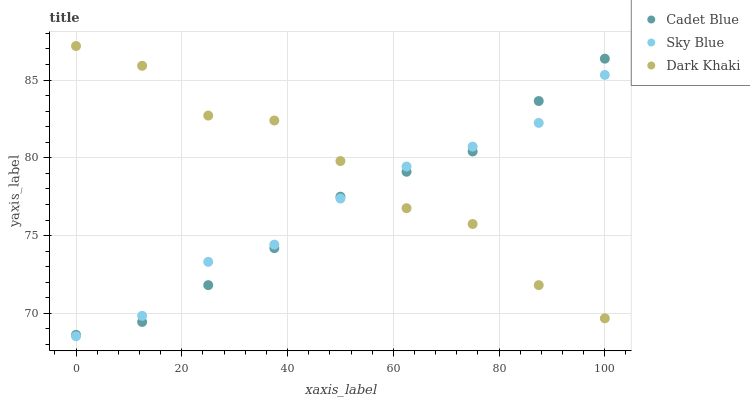Does Cadet Blue have the minimum area under the curve?
Answer yes or no. Yes. Does Dark Khaki have the maximum area under the curve?
Answer yes or no. Yes. Does Sky Blue have the minimum area under the curve?
Answer yes or no. No. Does Sky Blue have the maximum area under the curve?
Answer yes or no. No. Is Cadet Blue the smoothest?
Answer yes or no. Yes. Is Dark Khaki the roughest?
Answer yes or no. Yes. Is Sky Blue the smoothest?
Answer yes or no. No. Is Sky Blue the roughest?
Answer yes or no. No. Does Sky Blue have the lowest value?
Answer yes or no. Yes. Does Cadet Blue have the lowest value?
Answer yes or no. No. Does Dark Khaki have the highest value?
Answer yes or no. Yes. Does Cadet Blue have the highest value?
Answer yes or no. No. Does Sky Blue intersect Cadet Blue?
Answer yes or no. Yes. Is Sky Blue less than Cadet Blue?
Answer yes or no. No. Is Sky Blue greater than Cadet Blue?
Answer yes or no. No. 